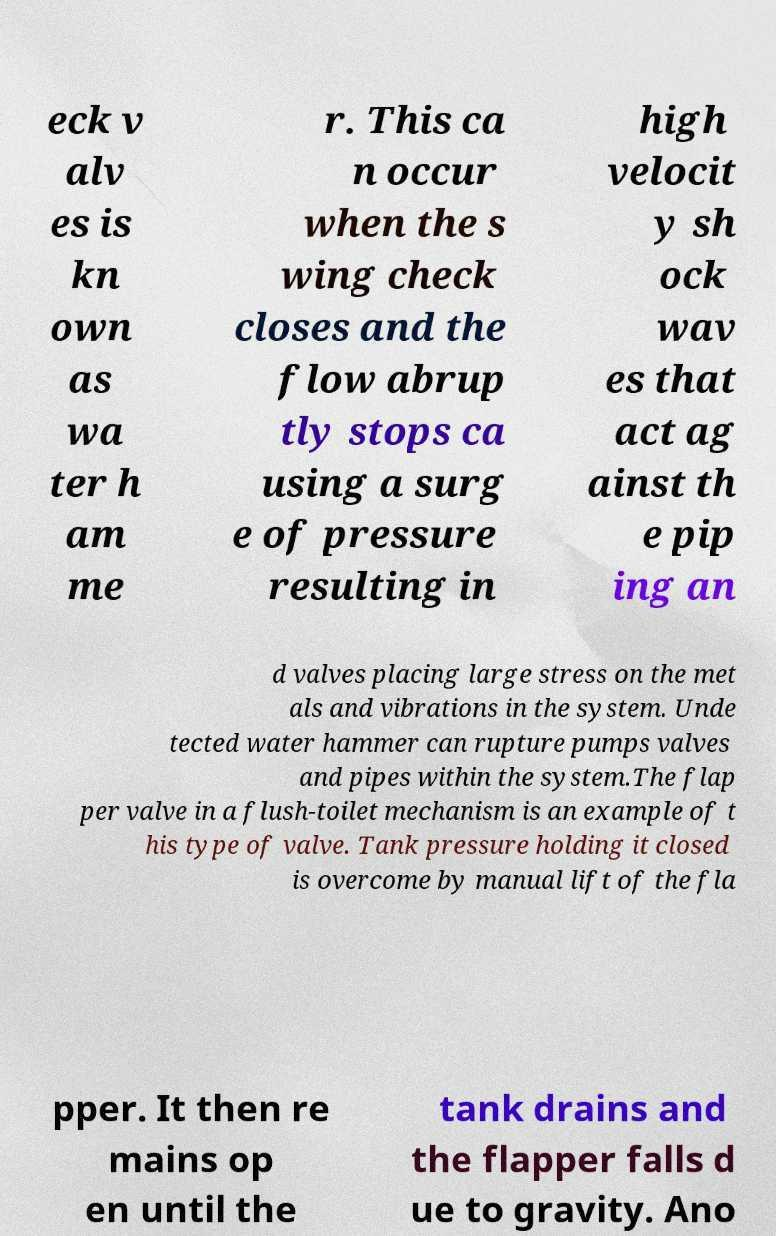Please read and relay the text visible in this image. What does it say? eck v alv es is kn own as wa ter h am me r. This ca n occur when the s wing check closes and the flow abrup tly stops ca using a surg e of pressure resulting in high velocit y sh ock wav es that act ag ainst th e pip ing an d valves placing large stress on the met als and vibrations in the system. Unde tected water hammer can rupture pumps valves and pipes within the system.The flap per valve in a flush-toilet mechanism is an example of t his type of valve. Tank pressure holding it closed is overcome by manual lift of the fla pper. It then re mains op en until the tank drains and the flapper falls d ue to gravity. Ano 